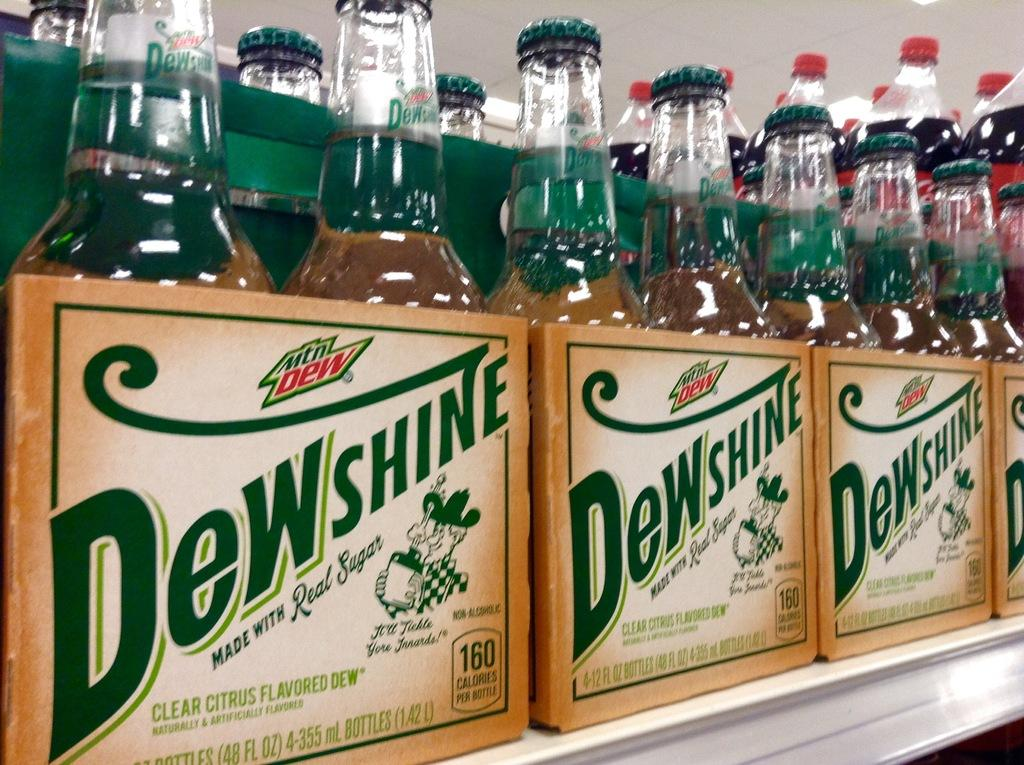<image>
Provide a brief description of the given image. Packaged bottles of Dewshine are lined up on a shelf. 